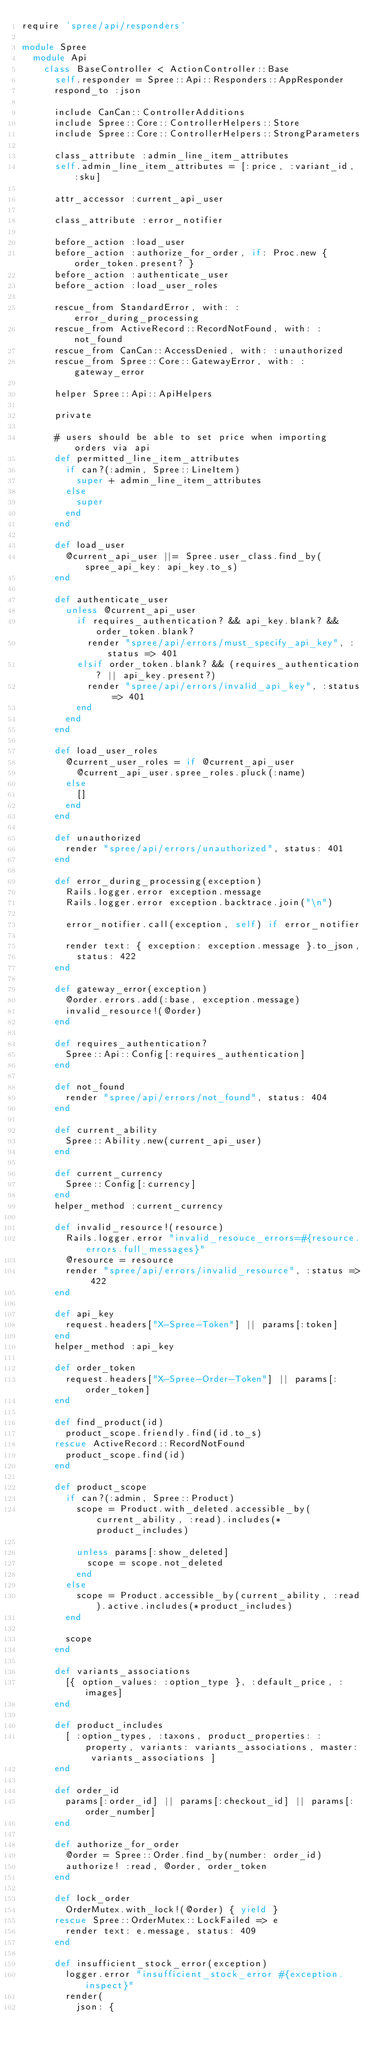Convert code to text. <code><loc_0><loc_0><loc_500><loc_500><_Ruby_>require 'spree/api/responders'

module Spree
  module Api
    class BaseController < ActionController::Base
      self.responder = Spree::Api::Responders::AppResponder
      respond_to :json

      include CanCan::ControllerAdditions
      include Spree::Core::ControllerHelpers::Store
      include Spree::Core::ControllerHelpers::StrongParameters

      class_attribute :admin_line_item_attributes
      self.admin_line_item_attributes = [:price, :variant_id, :sku]

      attr_accessor :current_api_user

      class_attribute :error_notifier

      before_action :load_user
      before_action :authorize_for_order, if: Proc.new { order_token.present? }
      before_action :authenticate_user
      before_action :load_user_roles

      rescue_from StandardError, with: :error_during_processing
      rescue_from ActiveRecord::RecordNotFound, with: :not_found
      rescue_from CanCan::AccessDenied, with: :unauthorized
      rescue_from Spree::Core::GatewayError, with: :gateway_error

      helper Spree::Api::ApiHelpers

      private

      # users should be able to set price when importing orders via api
      def permitted_line_item_attributes
        if can?(:admin, Spree::LineItem)
          super + admin_line_item_attributes
        else
          super
        end
      end

      def load_user
        @current_api_user ||= Spree.user_class.find_by(spree_api_key: api_key.to_s)
      end

      def authenticate_user
        unless @current_api_user
          if requires_authentication? && api_key.blank? && order_token.blank?
            render "spree/api/errors/must_specify_api_key", :status => 401
          elsif order_token.blank? && (requires_authentication? || api_key.present?)
            render "spree/api/errors/invalid_api_key", :status => 401
          end
        end
      end

      def load_user_roles
        @current_user_roles = if @current_api_user
          @current_api_user.spree_roles.pluck(:name)
        else
          []
        end
      end

      def unauthorized
        render "spree/api/errors/unauthorized", status: 401
      end

      def error_during_processing(exception)
        Rails.logger.error exception.message
        Rails.logger.error exception.backtrace.join("\n")

        error_notifier.call(exception, self) if error_notifier

        render text: { exception: exception.message }.to_json,
          status: 422
      end

      def gateway_error(exception)
        @order.errors.add(:base, exception.message)
        invalid_resource!(@order)
      end

      def requires_authentication?
        Spree::Api::Config[:requires_authentication]
      end

      def not_found
        render "spree/api/errors/not_found", status: 404
      end

      def current_ability
        Spree::Ability.new(current_api_user)
      end

      def current_currency
        Spree::Config[:currency]
      end
      helper_method :current_currency

      def invalid_resource!(resource)
        Rails.logger.error "invalid_resouce_errors=#{resource.errors.full_messages}"
        @resource = resource
        render "spree/api/errors/invalid_resource", :status => 422
      end

      def api_key
        request.headers["X-Spree-Token"] || params[:token]
      end
      helper_method :api_key

      def order_token
        request.headers["X-Spree-Order-Token"] || params[:order_token]
      end

      def find_product(id)
        product_scope.friendly.find(id.to_s)
      rescue ActiveRecord::RecordNotFound
        product_scope.find(id)
      end

      def product_scope
        if can?(:admin, Spree::Product)
          scope = Product.with_deleted.accessible_by(current_ability, :read).includes(*product_includes)

          unless params[:show_deleted]
            scope = scope.not_deleted
          end
        else
          scope = Product.accessible_by(current_ability, :read).active.includes(*product_includes)
        end

        scope
      end

      def variants_associations
        [{ option_values: :option_type }, :default_price, :images]
      end

      def product_includes
        [ :option_types, :taxons, product_properties: :property, variants: variants_associations, master: variants_associations ]
      end

      def order_id
        params[:order_id] || params[:checkout_id] || params[:order_number]
      end

      def authorize_for_order
        @order = Spree::Order.find_by(number: order_id)
        authorize! :read, @order, order_token
      end

      def lock_order
        OrderMutex.with_lock!(@order) { yield }
      rescue Spree::OrderMutex::LockFailed => e
        render text: e.message, status: 409
      end

      def insufficient_stock_error(exception)
        logger.error "insufficient_stock_error #{exception.inspect}"
        render(
          json: {</code> 